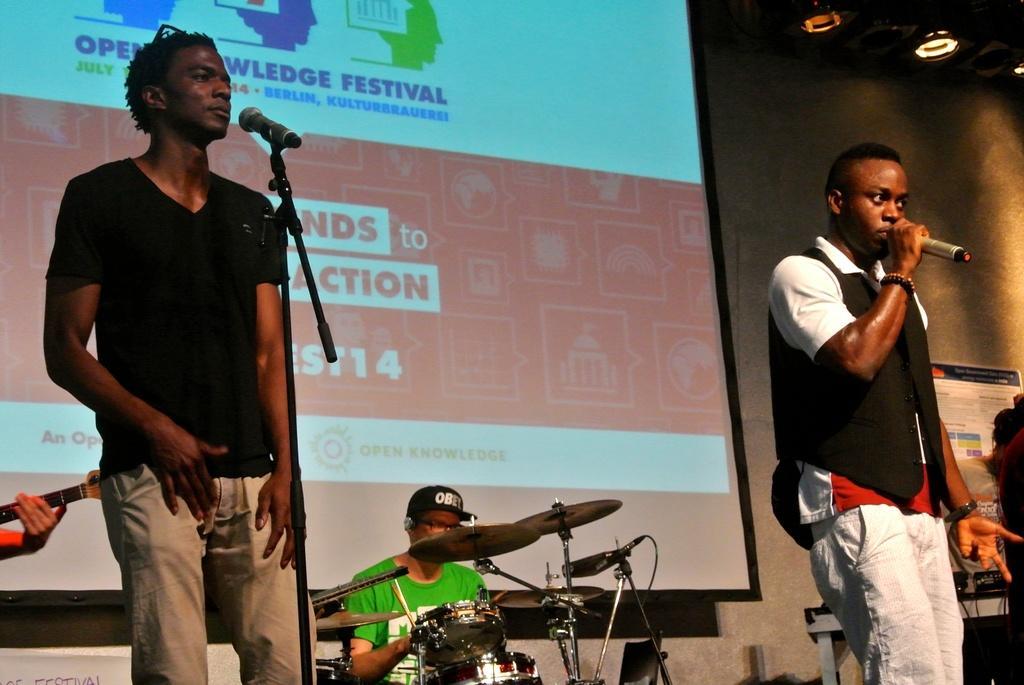In one or two sentences, can you explain what this image depicts? In the image on right side there is a man holding a microphone and singing, on left there is another man standing in front of microphone, in middle we can see a man sitting and playing his musical instruments. In background there is a screen on top there are few lights. 